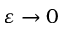<formula> <loc_0><loc_0><loc_500><loc_500>\varepsilon \rightarrow 0</formula> 